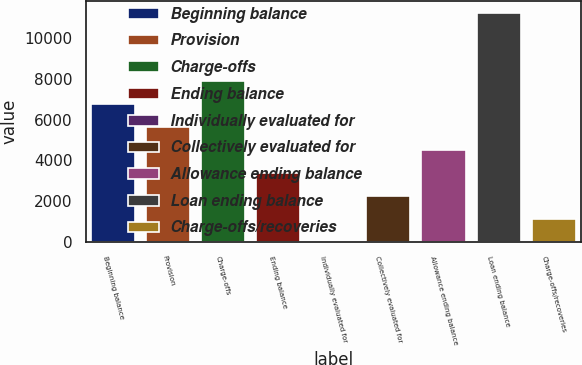<chart> <loc_0><loc_0><loc_500><loc_500><bar_chart><fcel>Beginning balance<fcel>Provision<fcel>Charge-offs<fcel>Ending balance<fcel>Individually evaluated for<fcel>Collectively evaluated for<fcel>Allowance ending balance<fcel>Loan ending balance<fcel>Charge-offs/recoveries<nl><fcel>6753.48<fcel>5630.3<fcel>7876.66<fcel>3383.94<fcel>14.4<fcel>2260.76<fcel>4507.12<fcel>11246.2<fcel>1137.58<nl></chart> 